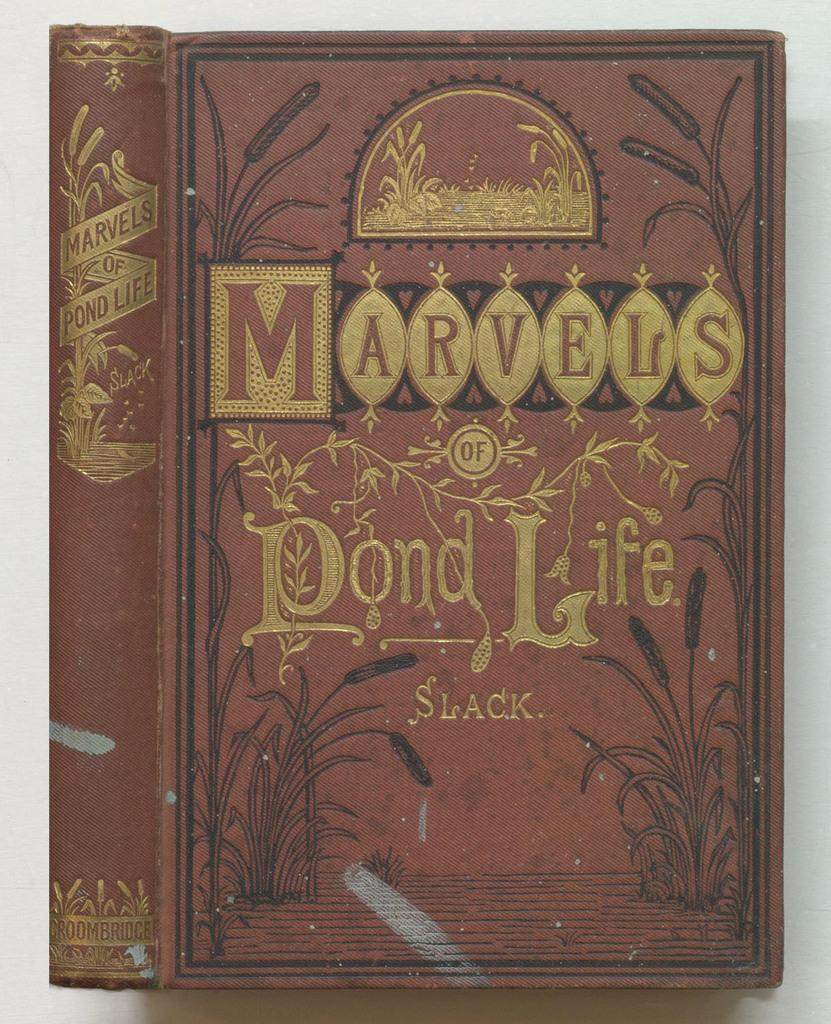<image>
Share a concise interpretation of the image provided. The cover and spine is shown of an old looking book called "Marvels of Pond Life." 